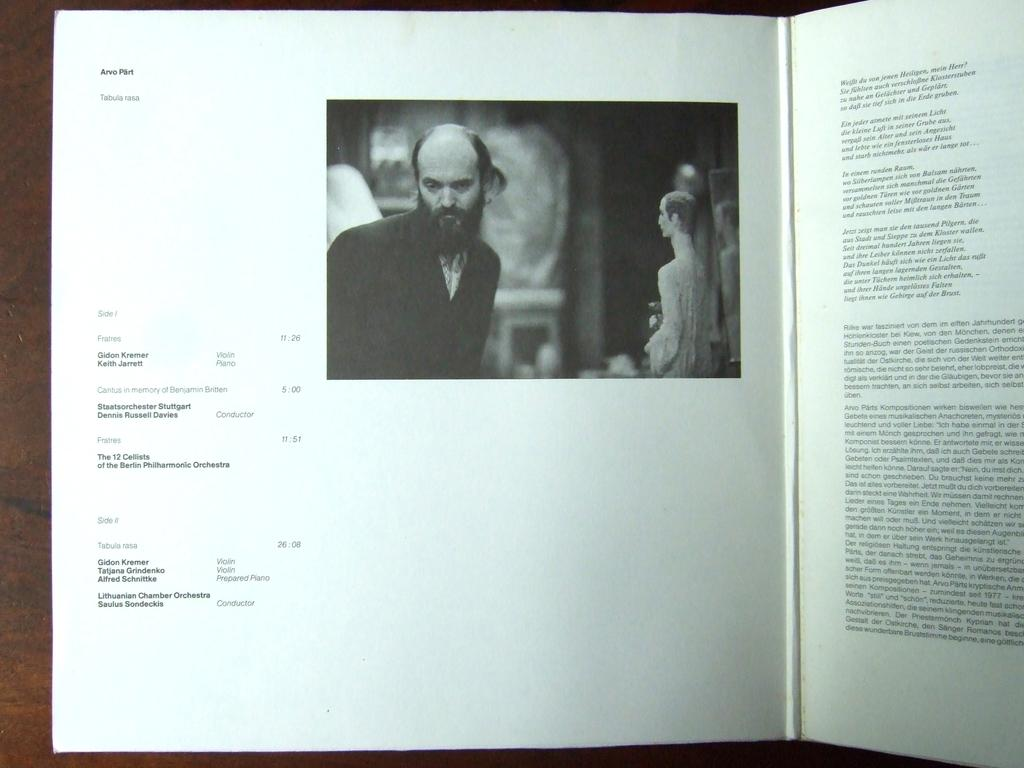What is the main object in the image? There is a book in the image. What is the book placed on? The book is on a wooden object. What else can be seen in the image besides the book? There is a photo on a paper in the image. What can be found inside the book? The papers of the book contain words and numbers. What level of heat can be felt from the book in the image? There is no indication of heat in the image, so it cannot be determined. 